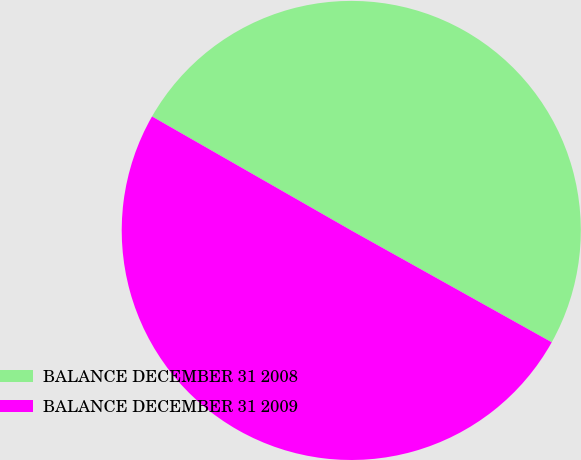<chart> <loc_0><loc_0><loc_500><loc_500><pie_chart><fcel>BALANCE DECEMBER 31 2008<fcel>BALANCE DECEMBER 31 2009<nl><fcel>49.83%<fcel>50.17%<nl></chart> 